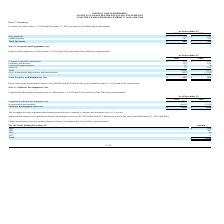According to Inpixon's financial document, What was the weighted average remaining amortization period for the Company’s software development costs? According to the financial document, 1.61 years. The relevant text states: "d for the Company’s software development costs is 1.61 years. Amortization expense for capitalized software development costs was $1.025 million and $1.2 millio..." Also, What was the net software development costs in 2019? According to the financial document, 1,544 (in thousands). The relevant text states: "Software development costs, net $ 1,544 $ 1,690..." Also, What was the Capitalized software development costs in 2019? According to the financial document, $6,029 (in thousands). The relevant text states: "Capitalized software development costs $ 6,029 $ 5,102..." Additionally, In which year was Capitalized software development costs less than 6,000 thousands? According to the financial document, 2018. The relevant text states: "TEMENTS FOR THE YEARS ENDED DECEMBER 31, 2019 AND 2018..." Also, can you calculate: What was the average Software development costs, net for 2018 and 2019? To answer this question, I need to perform calculations using the financial data. The calculation is: (1,544 + 1,690) / 2, which equals 1617 (in thousands). This is based on the information: "Software development costs, net $ 1,544 $ 1,690 Software development costs, net $ 1,544 $ 1,690..." The key data points involved are: 1,544, 1,690. Also, can you calculate: What was the change in Accumulated amortization from 2018 to 2019? Based on the calculation: -4,485 - (-3,412), the result is -1073 (in thousands). This is based on the information: "Accumulated amortization (4,485) (3,412) Accumulated amortization (4,485) (3,412)..." The key data points involved are: 3,412, 4,485. 